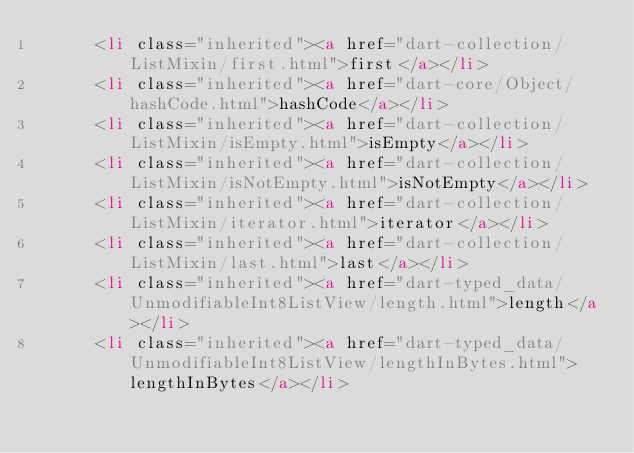<code> <loc_0><loc_0><loc_500><loc_500><_HTML_>      <li class="inherited"><a href="dart-collection/ListMixin/first.html">first</a></li>
      <li class="inherited"><a href="dart-core/Object/hashCode.html">hashCode</a></li>
      <li class="inherited"><a href="dart-collection/ListMixin/isEmpty.html">isEmpty</a></li>
      <li class="inherited"><a href="dart-collection/ListMixin/isNotEmpty.html">isNotEmpty</a></li>
      <li class="inherited"><a href="dart-collection/ListMixin/iterator.html">iterator</a></li>
      <li class="inherited"><a href="dart-collection/ListMixin/last.html">last</a></li>
      <li class="inherited"><a href="dart-typed_data/UnmodifiableInt8ListView/length.html">length</a></li>
      <li class="inherited"><a href="dart-typed_data/UnmodifiableInt8ListView/lengthInBytes.html">lengthInBytes</a></li></code> 